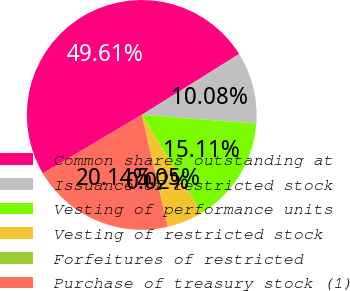Convert chart to OTSL. <chart><loc_0><loc_0><loc_500><loc_500><pie_chart><fcel>Common shares outstanding at<fcel>Issuance of restricted stock<fcel>Vesting of performance units<fcel>Vesting of restricted stock<fcel>Forfeitures of restricted<fcel>Purchase of treasury stock (1)<nl><fcel>49.61%<fcel>10.08%<fcel>15.11%<fcel>5.05%<fcel>0.02%<fcel>20.14%<nl></chart> 